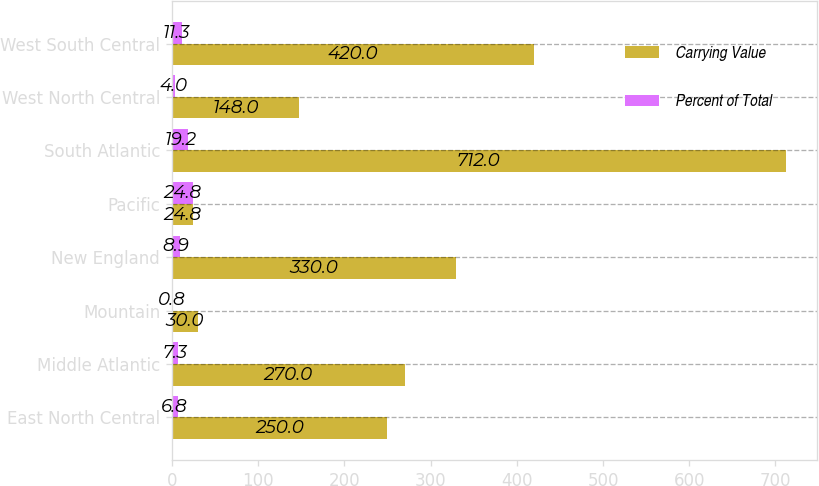Convert chart. <chart><loc_0><loc_0><loc_500><loc_500><stacked_bar_chart><ecel><fcel>East North Central<fcel>Middle Atlantic<fcel>Mountain<fcel>New England<fcel>Pacific<fcel>South Atlantic<fcel>West North Central<fcel>West South Central<nl><fcel>Carrying Value<fcel>250<fcel>270<fcel>30<fcel>330<fcel>24.8<fcel>712<fcel>148<fcel>420<nl><fcel>Percent of Total<fcel>6.8<fcel>7.3<fcel>0.8<fcel>8.9<fcel>24.8<fcel>19.2<fcel>4<fcel>11.3<nl></chart> 